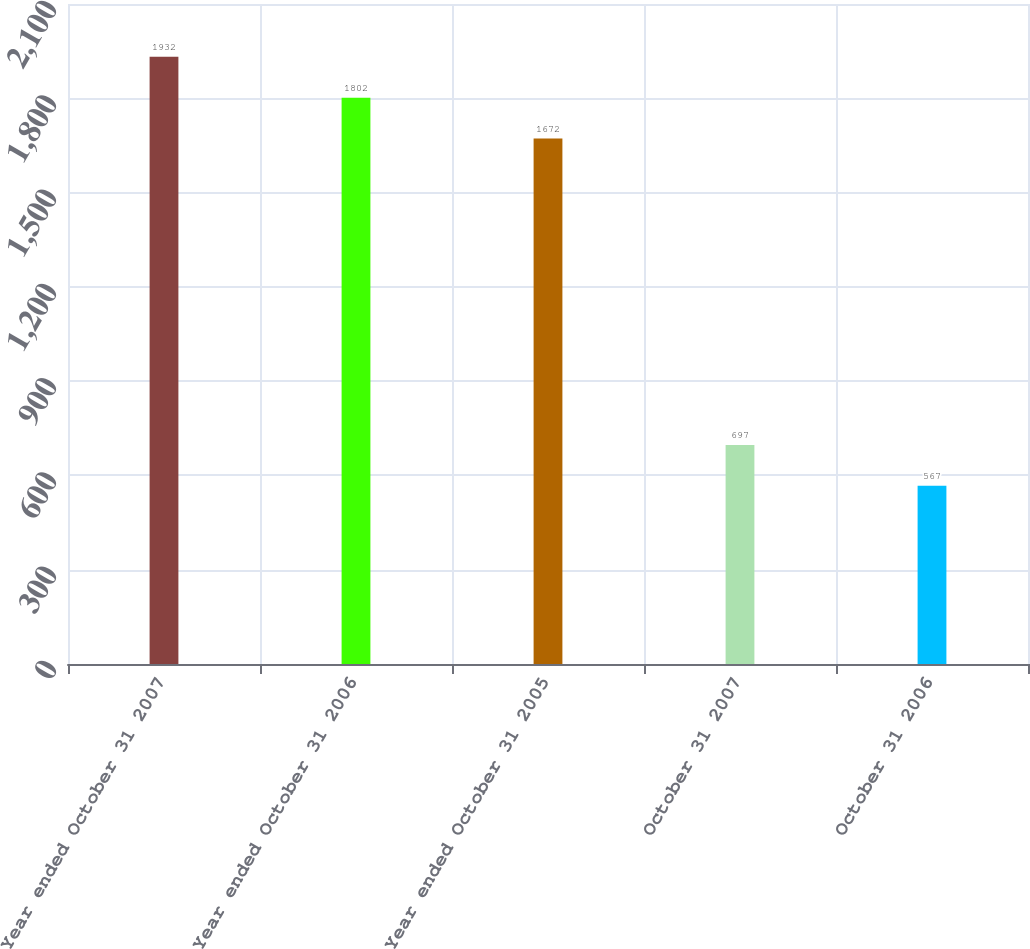Convert chart to OTSL. <chart><loc_0><loc_0><loc_500><loc_500><bar_chart><fcel>Year ended October 31 2007<fcel>Year ended October 31 2006<fcel>Year ended October 31 2005<fcel>October 31 2007<fcel>October 31 2006<nl><fcel>1932<fcel>1802<fcel>1672<fcel>697<fcel>567<nl></chart> 